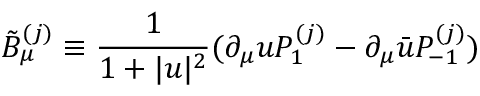<formula> <loc_0><loc_0><loc_500><loc_500>\tilde { B } _ { \mu } ^ { ( j ) } \equiv \frac { 1 } { 1 + | u | ^ { 2 } } ( \partial _ { \mu } u P _ { 1 } ^ { ( j ) } - \partial _ { \mu } \bar { u } P _ { - 1 } ^ { ( j ) } )</formula> 